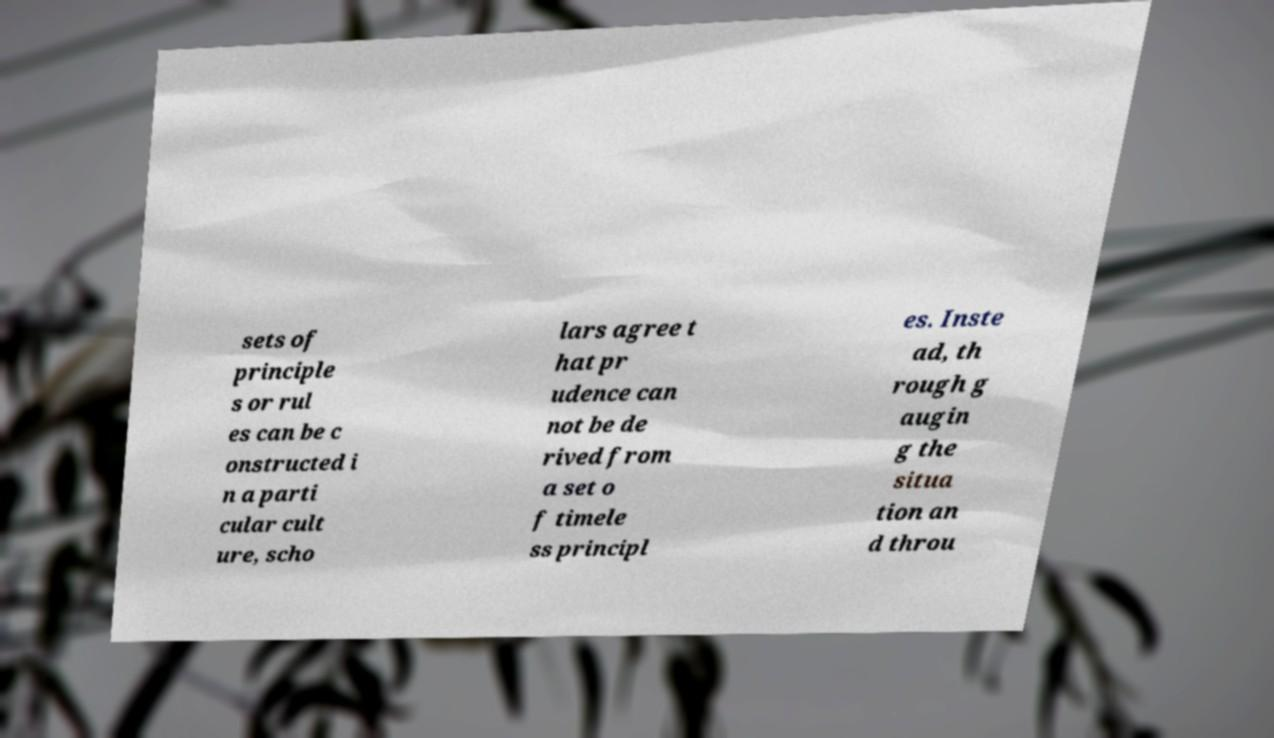Can you read and provide the text displayed in the image?This photo seems to have some interesting text. Can you extract and type it out for me? sets of principle s or rul es can be c onstructed i n a parti cular cult ure, scho lars agree t hat pr udence can not be de rived from a set o f timele ss principl es. Inste ad, th rough g augin g the situa tion an d throu 